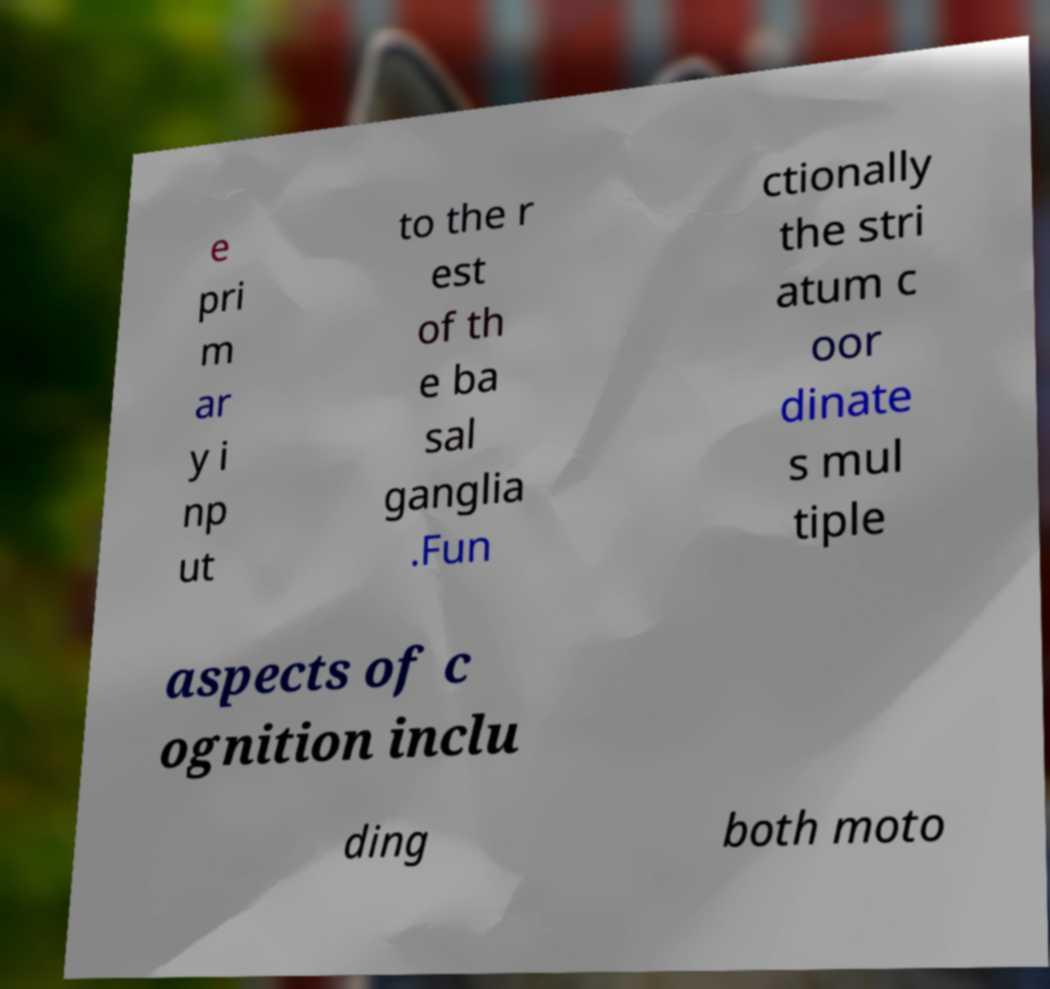Can you accurately transcribe the text from the provided image for me? e pri m ar y i np ut to the r est of th e ba sal ganglia .Fun ctionally the stri atum c oor dinate s mul tiple aspects of c ognition inclu ding both moto 